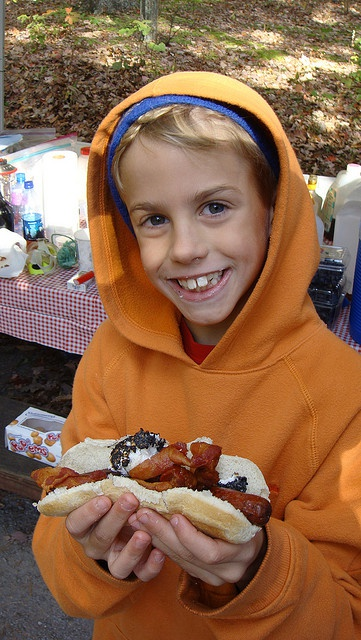Describe the objects in this image and their specific colors. I can see people in gray, brown, maroon, and orange tones, hot dog in gray, maroon, darkgray, brown, and lightgray tones, bottle in gray, white, lightblue, and darkgray tones, bottle in gray, lavender, darkgray, and lightblue tones, and bottle in gray, tan, ivory, and khaki tones in this image. 